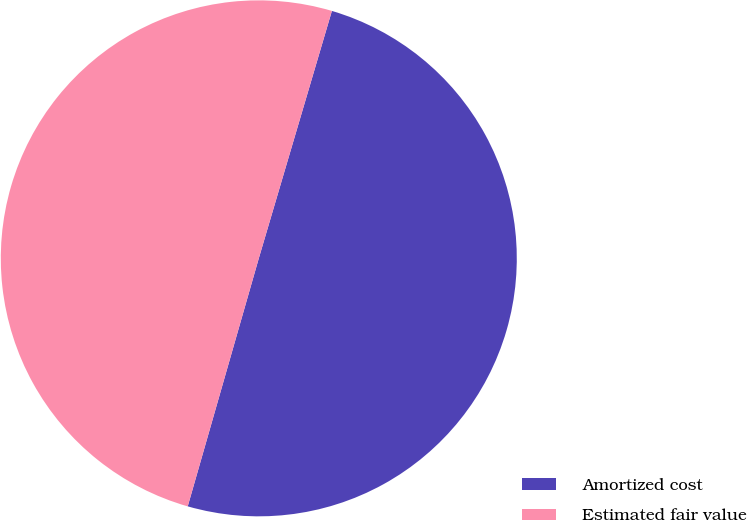Convert chart to OTSL. <chart><loc_0><loc_0><loc_500><loc_500><pie_chart><fcel>Amortized cost<fcel>Estimated fair value<nl><fcel>49.87%<fcel>50.13%<nl></chart> 